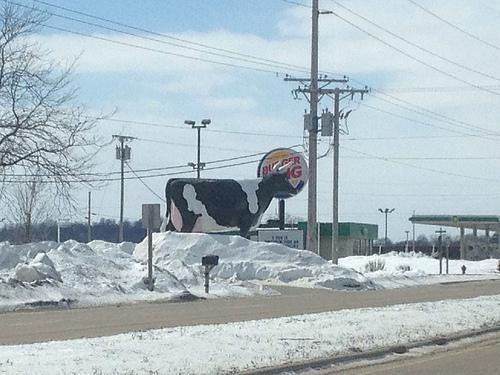How many roads do you see?
Give a very brief answer. 2. How many mailboxes are there?
Give a very brief answer. 1. How many horns does the bull have?
Give a very brief answer. 2. 